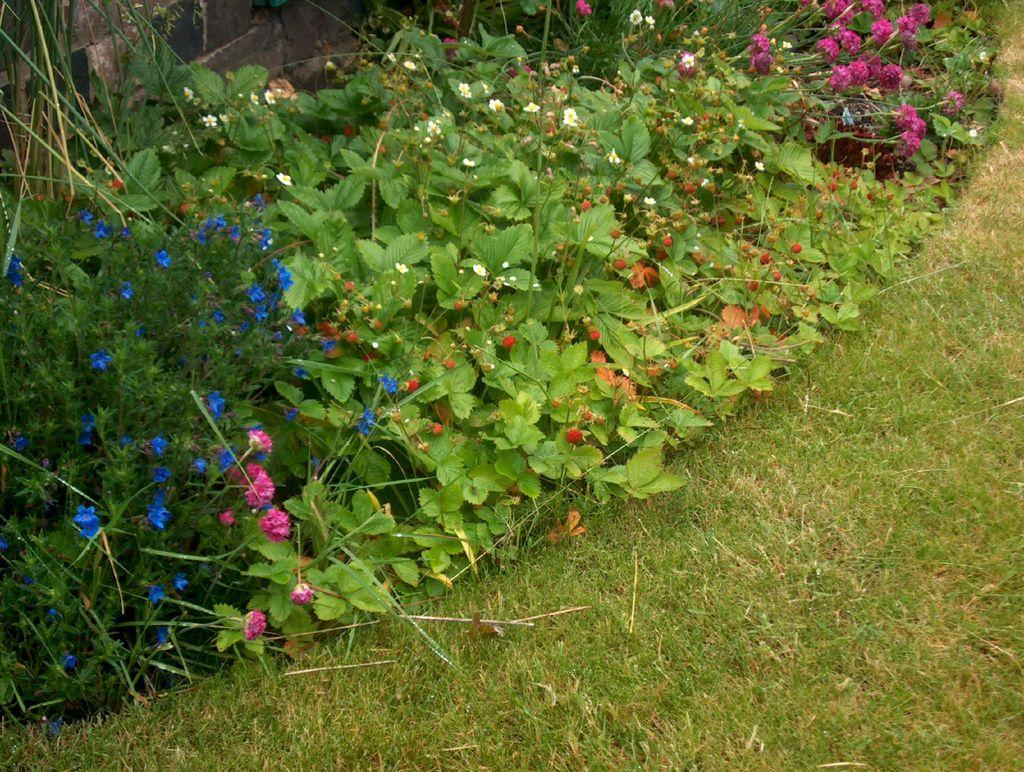What type of vegetation is in the center of the image? There is grass, plants, and a flower in the center of the image. What else can be seen in the center of the image besides vegetation? There are a few other objects in the center of the image. What type of hole can be seen in the center of the image? There is no hole present in the center of the image. Is there a farmer tending to the plants in the center of the image? There is no farmer present in the image. 